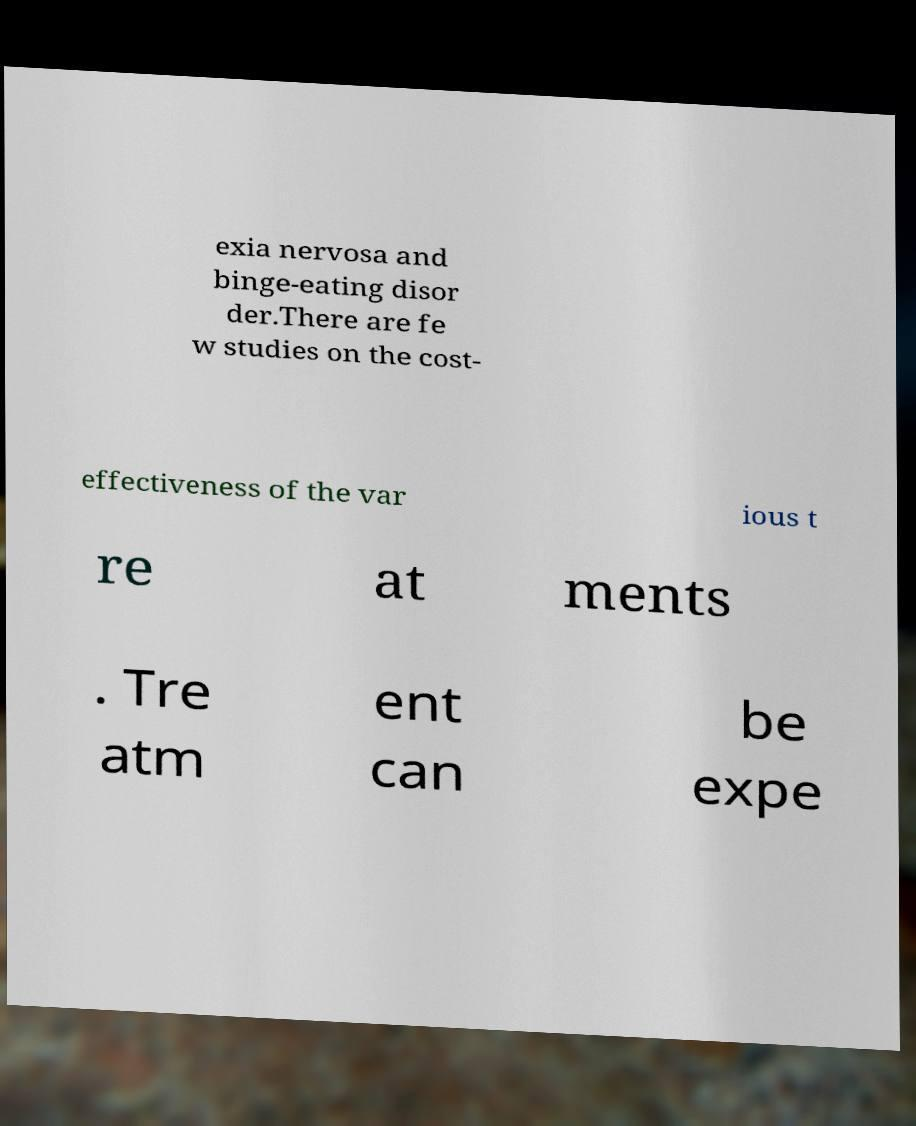What messages or text are displayed in this image? I need them in a readable, typed format. exia nervosa and binge-eating disor der.There are fe w studies on the cost- effectiveness of the var ious t re at ments . Tre atm ent can be expe 